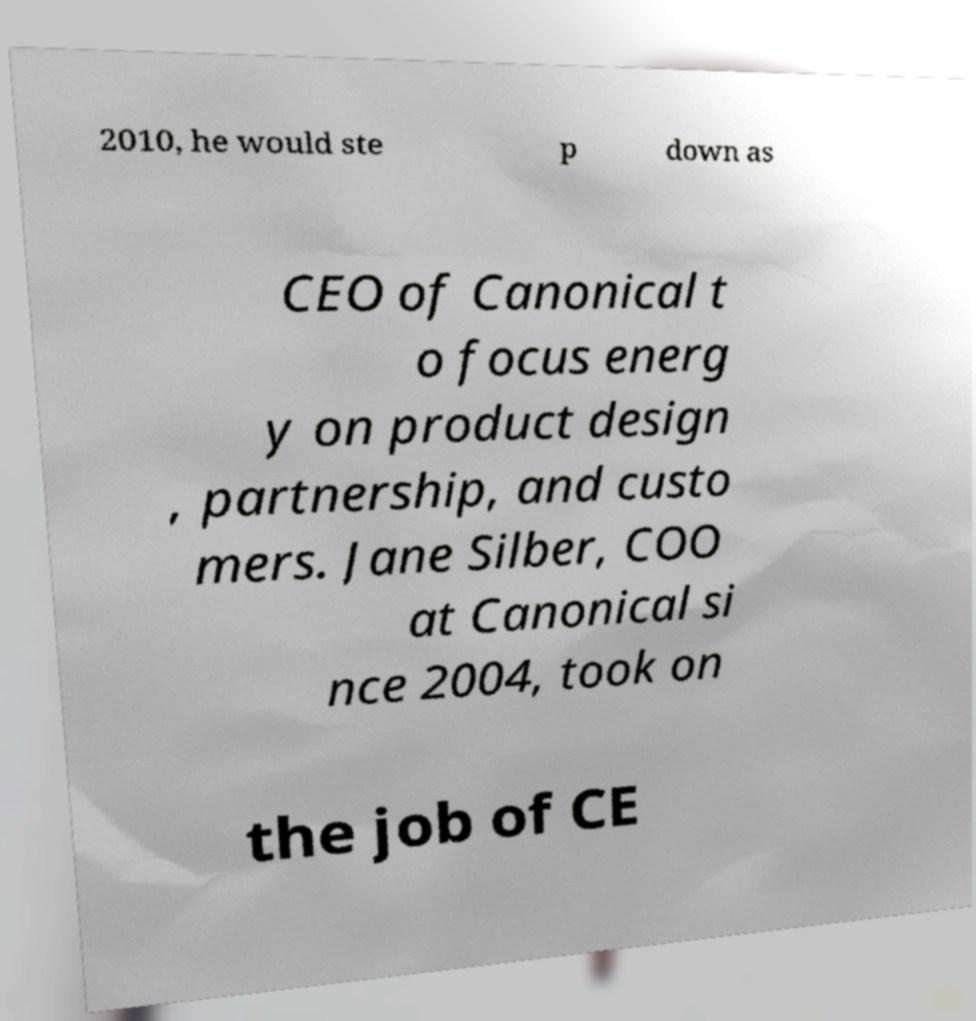For documentation purposes, I need the text within this image transcribed. Could you provide that? 2010, he would ste p down as CEO of Canonical t o focus energ y on product design , partnership, and custo mers. Jane Silber, COO at Canonical si nce 2004, took on the job of CE 